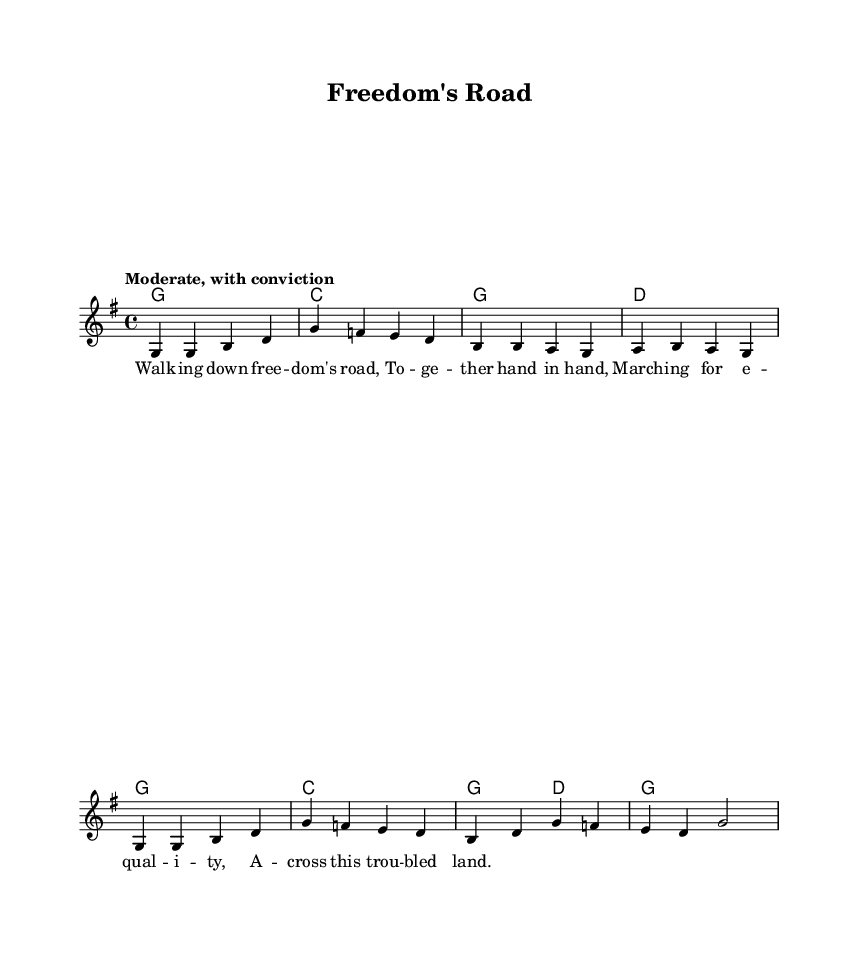What is the key signature of this music? The key signature is G major, which has one sharp (F#). This can be identified by looking for the sharps indicated at the beginning of the staff.
Answer: G major What is the time signature of this music? The time signature is 4/4, indicated at the beginning of the score. It signifies four beats per measure, with each beat represented by a quarter note.
Answer: 4/4 What is the tempo marking for this music? The tempo marking is "Moderate, with conviction" indicated at the beginning, suggesting a steady and confident pace.
Answer: Moderate, with conviction How many measures are in the melody? There are eight measures in the melody, which can be counted visually from the start of the melody section to the end of it.
Answer: Eight What is the last note of the melody? The last note of the melody is G, as seen in the last measure where the note is represented before the bar line ending the piece.
Answer: G What chords are used in the first measure? The chord used in the first measure is G major, as indicated in the chord section above the staff. The visual chord notation shows the notes G, B, and D.
Answer: G How many syllables are in the first line of the lyrics? The first line of the lyrics has six syllables: "Walk-ing down free-dom's road". This can be confirmed by counting each distinct syllable in that line.
Answer: Six 